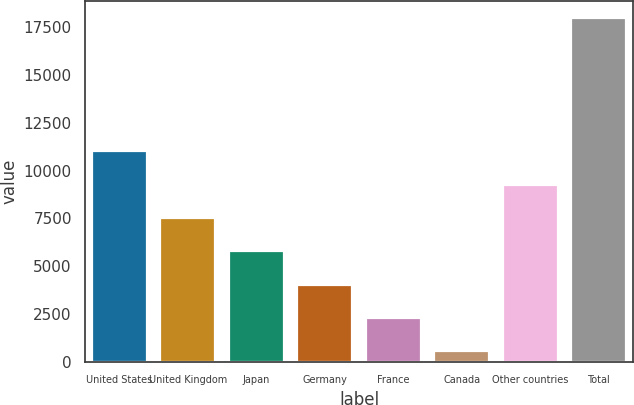Convert chart to OTSL. <chart><loc_0><loc_0><loc_500><loc_500><bar_chart><fcel>United States<fcel>United Kingdom<fcel>Japan<fcel>Germany<fcel>France<fcel>Canada<fcel>Other countries<fcel>Total<nl><fcel>11016.8<fcel>7527.2<fcel>5782.4<fcel>4037.6<fcel>2292.8<fcel>548<fcel>9272<fcel>17996<nl></chart> 